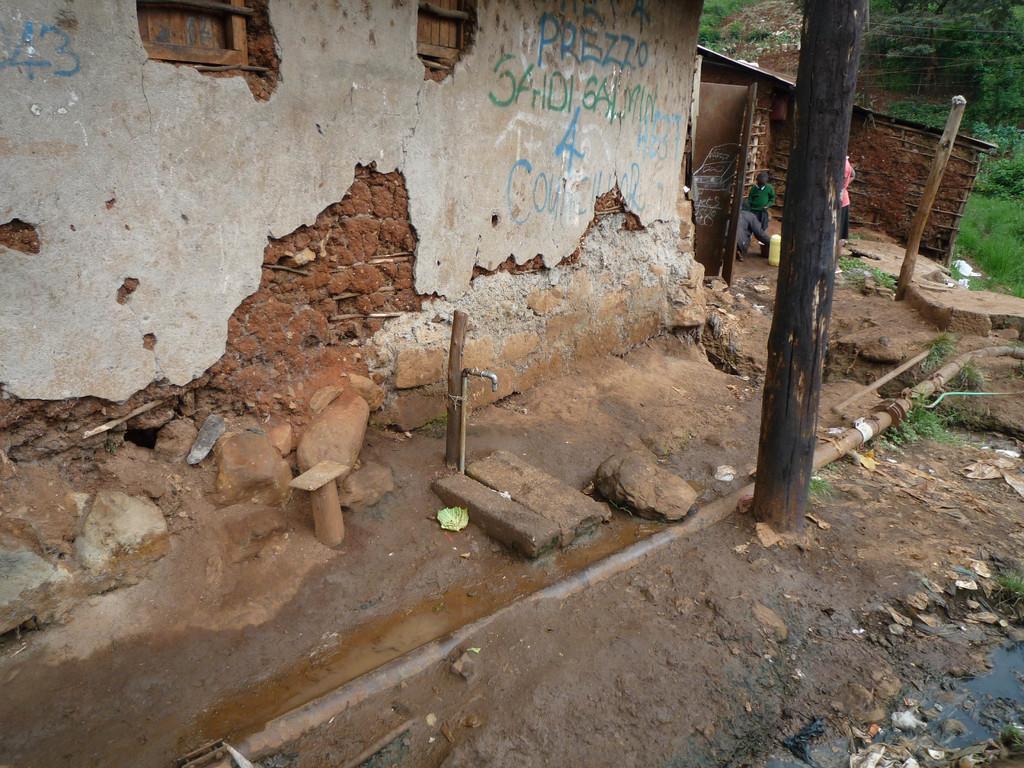Could you give a brief overview of what you see in this image? In the center of the image we can see the poles, waterstones, grass, one tap and a few other objects. In the background, we can see trees, wires, one pole, one building, few people, one can, grass, waste papers and a few other objects. And we can see some text on the wall. 